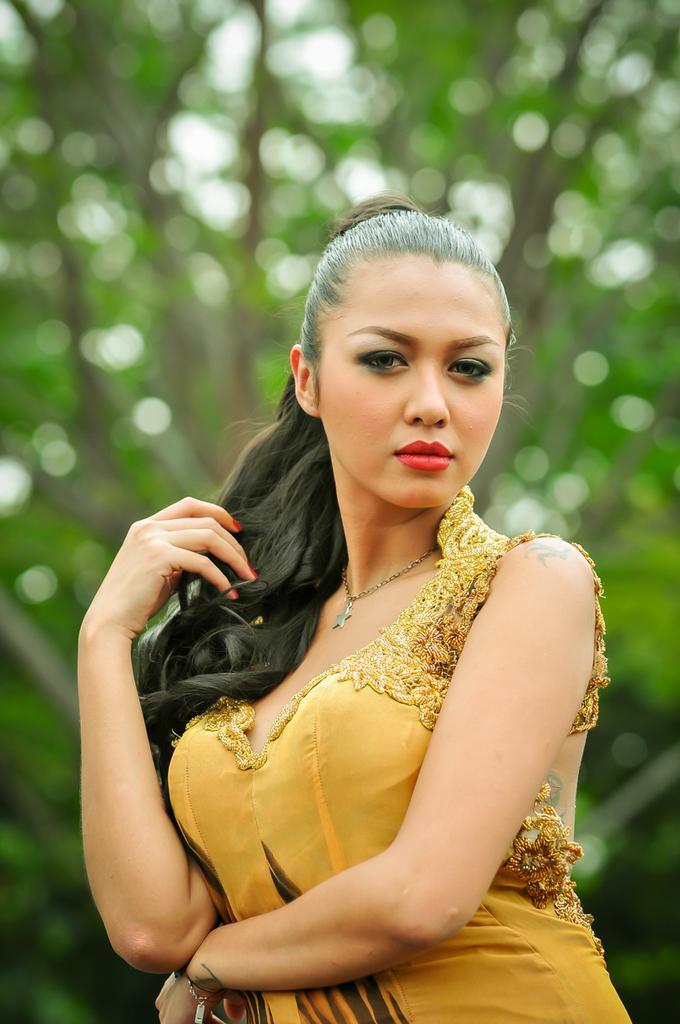How would you summarize this image in a sentence or two? In this picture I can see there is a woman standing and she is wearing a yellow color dress and a necklace. In the backdrop, it looks like there is a tree and the backdrop of the image is blurred. 